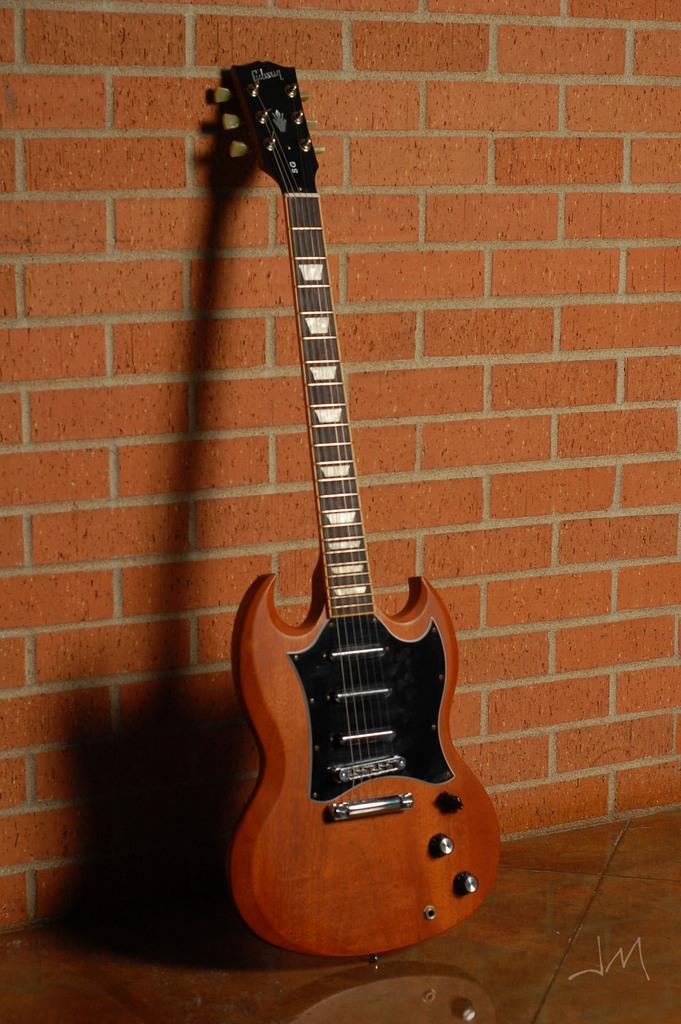What musical instrument is placed on the floor in the image? There is a guitar placed on the floor. What can be observed about the wall in the background of the image? The background wall is brick in color. How many pizzas are being served on the guitar in the image? There are no pizzas present in the image; it features a guitar placed on the floor. What type of match is being played in the image? There is no match or competition depicted in the image; it only shows a guitar placed on the floor and a brick-colored wall in the background. 